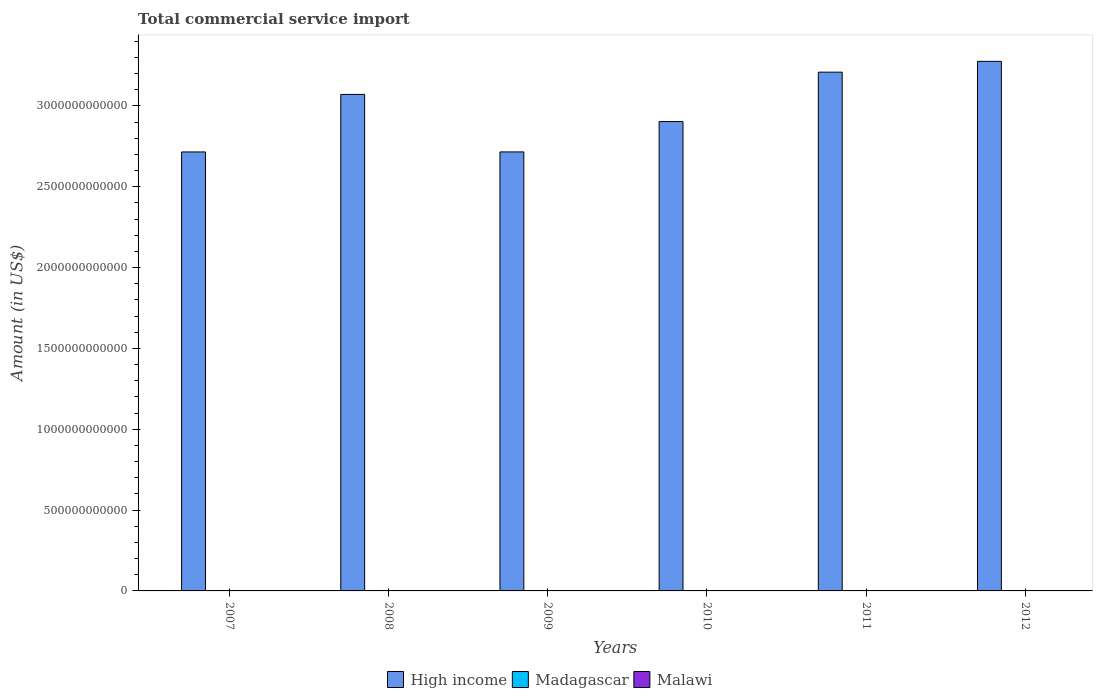How many different coloured bars are there?
Offer a terse response. 3. Are the number of bars on each tick of the X-axis equal?
Provide a succinct answer. Yes. What is the label of the 4th group of bars from the left?
Ensure brevity in your answer.  2010. What is the total commercial service import in Madagascar in 2010?
Give a very brief answer. 1.10e+09. Across all years, what is the maximum total commercial service import in High income?
Your answer should be very brief. 3.28e+12. Across all years, what is the minimum total commercial service import in Malawi?
Provide a succinct answer. 1.33e+08. In which year was the total commercial service import in High income maximum?
Keep it short and to the point. 2012. What is the total total commercial service import in High income in the graph?
Offer a very short reply. 1.79e+13. What is the difference between the total commercial service import in Madagascar in 2009 and that in 2012?
Provide a short and direct response. -4.01e+06. What is the difference between the total commercial service import in High income in 2008 and the total commercial service import in Madagascar in 2011?
Make the answer very short. 3.07e+12. What is the average total commercial service import in Madagascar per year?
Make the answer very short. 1.14e+09. In the year 2011, what is the difference between the total commercial service import in Madagascar and total commercial service import in Malawi?
Your answer should be very brief. 9.90e+08. What is the ratio of the total commercial service import in High income in 2008 to that in 2009?
Your answer should be very brief. 1.13. Is the difference between the total commercial service import in Madagascar in 2008 and 2009 greater than the difference between the total commercial service import in Malawi in 2008 and 2009?
Your answer should be compact. Yes. What is the difference between the highest and the second highest total commercial service import in Malawi?
Ensure brevity in your answer.  5.09e+07. What is the difference between the highest and the lowest total commercial service import in Malawi?
Give a very brief answer. 7.16e+07. Is the sum of the total commercial service import in Malawi in 2009 and 2010 greater than the maximum total commercial service import in Madagascar across all years?
Make the answer very short. No. What does the 3rd bar from the left in 2009 represents?
Offer a very short reply. Malawi. Is it the case that in every year, the sum of the total commercial service import in Madagascar and total commercial service import in High income is greater than the total commercial service import in Malawi?
Your answer should be compact. Yes. What is the difference between two consecutive major ticks on the Y-axis?
Give a very brief answer. 5.00e+11. Are the values on the major ticks of Y-axis written in scientific E-notation?
Offer a very short reply. No. Does the graph contain any zero values?
Provide a short and direct response. No. Does the graph contain grids?
Make the answer very short. No. Where does the legend appear in the graph?
Your response must be concise. Bottom center. How many legend labels are there?
Ensure brevity in your answer.  3. How are the legend labels stacked?
Provide a succinct answer. Horizontal. What is the title of the graph?
Offer a very short reply. Total commercial service import. Does "Azerbaijan" appear as one of the legend labels in the graph?
Offer a very short reply. No. What is the label or title of the X-axis?
Offer a terse response. Years. What is the label or title of the Y-axis?
Provide a succinct answer. Amount (in US$). What is the Amount (in US$) in High income in 2007?
Your response must be concise. 2.72e+12. What is the Amount (in US$) of Madagascar in 2007?
Give a very brief answer. 1.00e+09. What is the Amount (in US$) in Malawi in 2007?
Ensure brevity in your answer.  1.41e+08. What is the Amount (in US$) of High income in 2008?
Provide a succinct answer. 3.07e+12. What is the Amount (in US$) in Madagascar in 2008?
Your response must be concise. 1.35e+09. What is the Amount (in US$) in Malawi in 2008?
Make the answer very short. 1.33e+08. What is the Amount (in US$) in High income in 2009?
Your response must be concise. 2.72e+12. What is the Amount (in US$) of Madagascar in 2009?
Keep it short and to the point. 1.11e+09. What is the Amount (in US$) in Malawi in 2009?
Your answer should be compact. 1.36e+08. What is the Amount (in US$) of High income in 2010?
Offer a very short reply. 2.90e+12. What is the Amount (in US$) in Madagascar in 2010?
Provide a succinct answer. 1.10e+09. What is the Amount (in US$) in Malawi in 2010?
Ensure brevity in your answer.  1.35e+08. What is the Amount (in US$) in High income in 2011?
Give a very brief answer. 3.21e+12. What is the Amount (in US$) in Madagascar in 2011?
Your answer should be compact. 1.14e+09. What is the Amount (in US$) in Malawi in 2011?
Your answer should be compact. 1.54e+08. What is the Amount (in US$) in High income in 2012?
Your response must be concise. 3.28e+12. What is the Amount (in US$) of Madagascar in 2012?
Provide a short and direct response. 1.12e+09. What is the Amount (in US$) in Malawi in 2012?
Make the answer very short. 2.05e+08. Across all years, what is the maximum Amount (in US$) in High income?
Offer a very short reply. 3.28e+12. Across all years, what is the maximum Amount (in US$) of Madagascar?
Offer a very short reply. 1.35e+09. Across all years, what is the maximum Amount (in US$) in Malawi?
Provide a short and direct response. 2.05e+08. Across all years, what is the minimum Amount (in US$) in High income?
Make the answer very short. 2.72e+12. Across all years, what is the minimum Amount (in US$) of Madagascar?
Keep it short and to the point. 1.00e+09. Across all years, what is the minimum Amount (in US$) in Malawi?
Your response must be concise. 1.33e+08. What is the total Amount (in US$) of High income in the graph?
Make the answer very short. 1.79e+13. What is the total Amount (in US$) of Madagascar in the graph?
Provide a short and direct response. 6.83e+09. What is the total Amount (in US$) of Malawi in the graph?
Offer a very short reply. 9.04e+08. What is the difference between the Amount (in US$) in High income in 2007 and that in 2008?
Offer a terse response. -3.56e+11. What is the difference between the Amount (in US$) in Madagascar in 2007 and that in 2008?
Provide a short and direct response. -3.45e+08. What is the difference between the Amount (in US$) of Malawi in 2007 and that in 2008?
Offer a terse response. 7.50e+06. What is the difference between the Amount (in US$) of High income in 2007 and that in 2009?
Offer a very short reply. -1.42e+08. What is the difference between the Amount (in US$) of Madagascar in 2007 and that in 2009?
Offer a terse response. -1.09e+08. What is the difference between the Amount (in US$) of Malawi in 2007 and that in 2009?
Make the answer very short. 4.24e+06. What is the difference between the Amount (in US$) in High income in 2007 and that in 2010?
Your answer should be very brief. -1.88e+11. What is the difference between the Amount (in US$) in Madagascar in 2007 and that in 2010?
Ensure brevity in your answer.  -9.25e+07. What is the difference between the Amount (in US$) in Malawi in 2007 and that in 2010?
Your answer should be very brief. 5.56e+06. What is the difference between the Amount (in US$) of High income in 2007 and that in 2011?
Keep it short and to the point. -4.94e+11. What is the difference between the Amount (in US$) in Madagascar in 2007 and that in 2011?
Provide a short and direct response. -1.39e+08. What is the difference between the Amount (in US$) in Malawi in 2007 and that in 2011?
Your response must be concise. -1.32e+07. What is the difference between the Amount (in US$) in High income in 2007 and that in 2012?
Provide a short and direct response. -5.60e+11. What is the difference between the Amount (in US$) in Madagascar in 2007 and that in 2012?
Your answer should be compact. -1.13e+08. What is the difference between the Amount (in US$) in Malawi in 2007 and that in 2012?
Provide a succinct answer. -6.41e+07. What is the difference between the Amount (in US$) in High income in 2008 and that in 2009?
Keep it short and to the point. 3.56e+11. What is the difference between the Amount (in US$) in Madagascar in 2008 and that in 2009?
Your response must be concise. 2.36e+08. What is the difference between the Amount (in US$) of Malawi in 2008 and that in 2009?
Your response must be concise. -3.27e+06. What is the difference between the Amount (in US$) of High income in 2008 and that in 2010?
Provide a succinct answer. 1.68e+11. What is the difference between the Amount (in US$) in Madagascar in 2008 and that in 2010?
Give a very brief answer. 2.53e+08. What is the difference between the Amount (in US$) in Malawi in 2008 and that in 2010?
Your answer should be compact. -1.94e+06. What is the difference between the Amount (in US$) in High income in 2008 and that in 2011?
Your response must be concise. -1.38e+11. What is the difference between the Amount (in US$) in Madagascar in 2008 and that in 2011?
Keep it short and to the point. 2.07e+08. What is the difference between the Amount (in US$) of Malawi in 2008 and that in 2011?
Your answer should be compact. -2.07e+07. What is the difference between the Amount (in US$) in High income in 2008 and that in 2012?
Offer a terse response. -2.05e+11. What is the difference between the Amount (in US$) in Madagascar in 2008 and that in 2012?
Keep it short and to the point. 2.32e+08. What is the difference between the Amount (in US$) in Malawi in 2008 and that in 2012?
Keep it short and to the point. -7.16e+07. What is the difference between the Amount (in US$) in High income in 2009 and that in 2010?
Ensure brevity in your answer.  -1.88e+11. What is the difference between the Amount (in US$) of Madagascar in 2009 and that in 2010?
Offer a terse response. 1.64e+07. What is the difference between the Amount (in US$) of Malawi in 2009 and that in 2010?
Your response must be concise. 1.33e+06. What is the difference between the Amount (in US$) of High income in 2009 and that in 2011?
Give a very brief answer. -4.93e+11. What is the difference between the Amount (in US$) of Madagascar in 2009 and that in 2011?
Provide a succinct answer. -2.98e+07. What is the difference between the Amount (in US$) of Malawi in 2009 and that in 2011?
Provide a short and direct response. -1.74e+07. What is the difference between the Amount (in US$) in High income in 2009 and that in 2012?
Your answer should be very brief. -5.60e+11. What is the difference between the Amount (in US$) of Madagascar in 2009 and that in 2012?
Provide a succinct answer. -4.01e+06. What is the difference between the Amount (in US$) in Malawi in 2009 and that in 2012?
Give a very brief answer. -6.84e+07. What is the difference between the Amount (in US$) in High income in 2010 and that in 2011?
Your answer should be compact. -3.06e+11. What is the difference between the Amount (in US$) of Madagascar in 2010 and that in 2011?
Your answer should be very brief. -4.62e+07. What is the difference between the Amount (in US$) of Malawi in 2010 and that in 2011?
Your response must be concise. -1.87e+07. What is the difference between the Amount (in US$) of High income in 2010 and that in 2012?
Offer a very short reply. -3.72e+11. What is the difference between the Amount (in US$) of Madagascar in 2010 and that in 2012?
Ensure brevity in your answer.  -2.04e+07. What is the difference between the Amount (in US$) in Malawi in 2010 and that in 2012?
Ensure brevity in your answer.  -6.97e+07. What is the difference between the Amount (in US$) in High income in 2011 and that in 2012?
Provide a short and direct response. -6.69e+1. What is the difference between the Amount (in US$) of Madagascar in 2011 and that in 2012?
Your answer should be compact. 2.58e+07. What is the difference between the Amount (in US$) in Malawi in 2011 and that in 2012?
Provide a short and direct response. -5.09e+07. What is the difference between the Amount (in US$) of High income in 2007 and the Amount (in US$) of Madagascar in 2008?
Provide a succinct answer. 2.71e+12. What is the difference between the Amount (in US$) of High income in 2007 and the Amount (in US$) of Malawi in 2008?
Make the answer very short. 2.72e+12. What is the difference between the Amount (in US$) in Madagascar in 2007 and the Amount (in US$) in Malawi in 2008?
Keep it short and to the point. 8.72e+08. What is the difference between the Amount (in US$) in High income in 2007 and the Amount (in US$) in Madagascar in 2009?
Keep it short and to the point. 2.71e+12. What is the difference between the Amount (in US$) of High income in 2007 and the Amount (in US$) of Malawi in 2009?
Provide a succinct answer. 2.72e+12. What is the difference between the Amount (in US$) of Madagascar in 2007 and the Amount (in US$) of Malawi in 2009?
Offer a terse response. 8.69e+08. What is the difference between the Amount (in US$) in High income in 2007 and the Amount (in US$) in Madagascar in 2010?
Your answer should be very brief. 2.71e+12. What is the difference between the Amount (in US$) of High income in 2007 and the Amount (in US$) of Malawi in 2010?
Your answer should be compact. 2.72e+12. What is the difference between the Amount (in US$) of Madagascar in 2007 and the Amount (in US$) of Malawi in 2010?
Give a very brief answer. 8.70e+08. What is the difference between the Amount (in US$) of High income in 2007 and the Amount (in US$) of Madagascar in 2011?
Your answer should be compact. 2.71e+12. What is the difference between the Amount (in US$) in High income in 2007 and the Amount (in US$) in Malawi in 2011?
Your answer should be very brief. 2.72e+12. What is the difference between the Amount (in US$) in Madagascar in 2007 and the Amount (in US$) in Malawi in 2011?
Give a very brief answer. 8.51e+08. What is the difference between the Amount (in US$) in High income in 2007 and the Amount (in US$) in Madagascar in 2012?
Offer a terse response. 2.71e+12. What is the difference between the Amount (in US$) of High income in 2007 and the Amount (in US$) of Malawi in 2012?
Provide a succinct answer. 2.72e+12. What is the difference between the Amount (in US$) in Madagascar in 2007 and the Amount (in US$) in Malawi in 2012?
Keep it short and to the point. 8.00e+08. What is the difference between the Amount (in US$) of High income in 2008 and the Amount (in US$) of Madagascar in 2009?
Offer a very short reply. 3.07e+12. What is the difference between the Amount (in US$) in High income in 2008 and the Amount (in US$) in Malawi in 2009?
Give a very brief answer. 3.07e+12. What is the difference between the Amount (in US$) of Madagascar in 2008 and the Amount (in US$) of Malawi in 2009?
Offer a very short reply. 1.21e+09. What is the difference between the Amount (in US$) of High income in 2008 and the Amount (in US$) of Madagascar in 2010?
Offer a very short reply. 3.07e+12. What is the difference between the Amount (in US$) in High income in 2008 and the Amount (in US$) in Malawi in 2010?
Your response must be concise. 3.07e+12. What is the difference between the Amount (in US$) of Madagascar in 2008 and the Amount (in US$) of Malawi in 2010?
Your response must be concise. 1.22e+09. What is the difference between the Amount (in US$) of High income in 2008 and the Amount (in US$) of Madagascar in 2011?
Provide a succinct answer. 3.07e+12. What is the difference between the Amount (in US$) of High income in 2008 and the Amount (in US$) of Malawi in 2011?
Your answer should be very brief. 3.07e+12. What is the difference between the Amount (in US$) in Madagascar in 2008 and the Amount (in US$) in Malawi in 2011?
Provide a short and direct response. 1.20e+09. What is the difference between the Amount (in US$) in High income in 2008 and the Amount (in US$) in Madagascar in 2012?
Your response must be concise. 3.07e+12. What is the difference between the Amount (in US$) of High income in 2008 and the Amount (in US$) of Malawi in 2012?
Keep it short and to the point. 3.07e+12. What is the difference between the Amount (in US$) of Madagascar in 2008 and the Amount (in US$) of Malawi in 2012?
Give a very brief answer. 1.15e+09. What is the difference between the Amount (in US$) of High income in 2009 and the Amount (in US$) of Madagascar in 2010?
Offer a terse response. 2.71e+12. What is the difference between the Amount (in US$) in High income in 2009 and the Amount (in US$) in Malawi in 2010?
Your answer should be very brief. 2.72e+12. What is the difference between the Amount (in US$) in Madagascar in 2009 and the Amount (in US$) in Malawi in 2010?
Your response must be concise. 9.79e+08. What is the difference between the Amount (in US$) in High income in 2009 and the Amount (in US$) in Madagascar in 2011?
Your answer should be compact. 2.71e+12. What is the difference between the Amount (in US$) in High income in 2009 and the Amount (in US$) in Malawi in 2011?
Provide a short and direct response. 2.72e+12. What is the difference between the Amount (in US$) of Madagascar in 2009 and the Amount (in US$) of Malawi in 2011?
Offer a very short reply. 9.60e+08. What is the difference between the Amount (in US$) in High income in 2009 and the Amount (in US$) in Madagascar in 2012?
Your response must be concise. 2.71e+12. What is the difference between the Amount (in US$) of High income in 2009 and the Amount (in US$) of Malawi in 2012?
Your answer should be very brief. 2.72e+12. What is the difference between the Amount (in US$) of Madagascar in 2009 and the Amount (in US$) of Malawi in 2012?
Offer a terse response. 9.09e+08. What is the difference between the Amount (in US$) in High income in 2010 and the Amount (in US$) in Madagascar in 2011?
Give a very brief answer. 2.90e+12. What is the difference between the Amount (in US$) of High income in 2010 and the Amount (in US$) of Malawi in 2011?
Ensure brevity in your answer.  2.90e+12. What is the difference between the Amount (in US$) in Madagascar in 2010 and the Amount (in US$) in Malawi in 2011?
Provide a short and direct response. 9.44e+08. What is the difference between the Amount (in US$) in High income in 2010 and the Amount (in US$) in Madagascar in 2012?
Provide a short and direct response. 2.90e+12. What is the difference between the Amount (in US$) in High income in 2010 and the Amount (in US$) in Malawi in 2012?
Offer a very short reply. 2.90e+12. What is the difference between the Amount (in US$) in Madagascar in 2010 and the Amount (in US$) in Malawi in 2012?
Your answer should be very brief. 8.93e+08. What is the difference between the Amount (in US$) in High income in 2011 and the Amount (in US$) in Madagascar in 2012?
Ensure brevity in your answer.  3.21e+12. What is the difference between the Amount (in US$) in High income in 2011 and the Amount (in US$) in Malawi in 2012?
Keep it short and to the point. 3.21e+12. What is the difference between the Amount (in US$) of Madagascar in 2011 and the Amount (in US$) of Malawi in 2012?
Your response must be concise. 9.39e+08. What is the average Amount (in US$) of High income per year?
Make the answer very short. 2.98e+12. What is the average Amount (in US$) in Madagascar per year?
Offer a very short reply. 1.14e+09. What is the average Amount (in US$) in Malawi per year?
Your answer should be very brief. 1.51e+08. In the year 2007, what is the difference between the Amount (in US$) of High income and Amount (in US$) of Madagascar?
Your answer should be compact. 2.71e+12. In the year 2007, what is the difference between the Amount (in US$) in High income and Amount (in US$) in Malawi?
Your answer should be very brief. 2.72e+12. In the year 2007, what is the difference between the Amount (in US$) in Madagascar and Amount (in US$) in Malawi?
Ensure brevity in your answer.  8.64e+08. In the year 2008, what is the difference between the Amount (in US$) in High income and Amount (in US$) in Madagascar?
Offer a terse response. 3.07e+12. In the year 2008, what is the difference between the Amount (in US$) of High income and Amount (in US$) of Malawi?
Your answer should be compact. 3.07e+12. In the year 2008, what is the difference between the Amount (in US$) of Madagascar and Amount (in US$) of Malawi?
Your answer should be compact. 1.22e+09. In the year 2009, what is the difference between the Amount (in US$) of High income and Amount (in US$) of Madagascar?
Offer a terse response. 2.71e+12. In the year 2009, what is the difference between the Amount (in US$) in High income and Amount (in US$) in Malawi?
Offer a terse response. 2.72e+12. In the year 2009, what is the difference between the Amount (in US$) in Madagascar and Amount (in US$) in Malawi?
Your answer should be compact. 9.77e+08. In the year 2010, what is the difference between the Amount (in US$) in High income and Amount (in US$) in Madagascar?
Your answer should be very brief. 2.90e+12. In the year 2010, what is the difference between the Amount (in US$) of High income and Amount (in US$) of Malawi?
Give a very brief answer. 2.90e+12. In the year 2010, what is the difference between the Amount (in US$) in Madagascar and Amount (in US$) in Malawi?
Provide a succinct answer. 9.62e+08. In the year 2011, what is the difference between the Amount (in US$) of High income and Amount (in US$) of Madagascar?
Make the answer very short. 3.21e+12. In the year 2011, what is the difference between the Amount (in US$) in High income and Amount (in US$) in Malawi?
Offer a terse response. 3.21e+12. In the year 2011, what is the difference between the Amount (in US$) of Madagascar and Amount (in US$) of Malawi?
Your response must be concise. 9.90e+08. In the year 2012, what is the difference between the Amount (in US$) of High income and Amount (in US$) of Madagascar?
Offer a very short reply. 3.27e+12. In the year 2012, what is the difference between the Amount (in US$) of High income and Amount (in US$) of Malawi?
Provide a short and direct response. 3.28e+12. In the year 2012, what is the difference between the Amount (in US$) of Madagascar and Amount (in US$) of Malawi?
Give a very brief answer. 9.13e+08. What is the ratio of the Amount (in US$) of High income in 2007 to that in 2008?
Your response must be concise. 0.88. What is the ratio of the Amount (in US$) in Madagascar in 2007 to that in 2008?
Offer a terse response. 0.74. What is the ratio of the Amount (in US$) in Malawi in 2007 to that in 2008?
Make the answer very short. 1.06. What is the ratio of the Amount (in US$) in Madagascar in 2007 to that in 2009?
Provide a succinct answer. 0.9. What is the ratio of the Amount (in US$) in Malawi in 2007 to that in 2009?
Make the answer very short. 1.03. What is the ratio of the Amount (in US$) of High income in 2007 to that in 2010?
Your response must be concise. 0.94. What is the ratio of the Amount (in US$) in Madagascar in 2007 to that in 2010?
Your answer should be compact. 0.92. What is the ratio of the Amount (in US$) of Malawi in 2007 to that in 2010?
Ensure brevity in your answer.  1.04. What is the ratio of the Amount (in US$) of High income in 2007 to that in 2011?
Offer a very short reply. 0.85. What is the ratio of the Amount (in US$) of Madagascar in 2007 to that in 2011?
Offer a terse response. 0.88. What is the ratio of the Amount (in US$) of Malawi in 2007 to that in 2011?
Provide a short and direct response. 0.91. What is the ratio of the Amount (in US$) of High income in 2007 to that in 2012?
Provide a succinct answer. 0.83. What is the ratio of the Amount (in US$) in Madagascar in 2007 to that in 2012?
Provide a short and direct response. 0.9. What is the ratio of the Amount (in US$) in Malawi in 2007 to that in 2012?
Provide a succinct answer. 0.69. What is the ratio of the Amount (in US$) of High income in 2008 to that in 2009?
Offer a terse response. 1.13. What is the ratio of the Amount (in US$) in Madagascar in 2008 to that in 2009?
Your response must be concise. 1.21. What is the ratio of the Amount (in US$) in Malawi in 2008 to that in 2009?
Your answer should be very brief. 0.98. What is the ratio of the Amount (in US$) of High income in 2008 to that in 2010?
Offer a terse response. 1.06. What is the ratio of the Amount (in US$) of Madagascar in 2008 to that in 2010?
Offer a very short reply. 1.23. What is the ratio of the Amount (in US$) in Malawi in 2008 to that in 2010?
Keep it short and to the point. 0.99. What is the ratio of the Amount (in US$) of High income in 2008 to that in 2011?
Your answer should be very brief. 0.96. What is the ratio of the Amount (in US$) in Madagascar in 2008 to that in 2011?
Provide a short and direct response. 1.18. What is the ratio of the Amount (in US$) of Malawi in 2008 to that in 2011?
Provide a short and direct response. 0.87. What is the ratio of the Amount (in US$) of High income in 2008 to that in 2012?
Ensure brevity in your answer.  0.94. What is the ratio of the Amount (in US$) in Madagascar in 2008 to that in 2012?
Your answer should be very brief. 1.21. What is the ratio of the Amount (in US$) in Malawi in 2008 to that in 2012?
Your answer should be very brief. 0.65. What is the ratio of the Amount (in US$) of High income in 2009 to that in 2010?
Your answer should be very brief. 0.94. What is the ratio of the Amount (in US$) in Madagascar in 2009 to that in 2010?
Your answer should be very brief. 1.01. What is the ratio of the Amount (in US$) in Malawi in 2009 to that in 2010?
Give a very brief answer. 1.01. What is the ratio of the Amount (in US$) of High income in 2009 to that in 2011?
Your response must be concise. 0.85. What is the ratio of the Amount (in US$) in Madagascar in 2009 to that in 2011?
Your response must be concise. 0.97. What is the ratio of the Amount (in US$) of Malawi in 2009 to that in 2011?
Ensure brevity in your answer.  0.89. What is the ratio of the Amount (in US$) of High income in 2009 to that in 2012?
Your answer should be compact. 0.83. What is the ratio of the Amount (in US$) of Malawi in 2009 to that in 2012?
Make the answer very short. 0.67. What is the ratio of the Amount (in US$) in High income in 2010 to that in 2011?
Offer a very short reply. 0.9. What is the ratio of the Amount (in US$) in Madagascar in 2010 to that in 2011?
Provide a short and direct response. 0.96. What is the ratio of the Amount (in US$) of Malawi in 2010 to that in 2011?
Provide a succinct answer. 0.88. What is the ratio of the Amount (in US$) in High income in 2010 to that in 2012?
Offer a very short reply. 0.89. What is the ratio of the Amount (in US$) of Madagascar in 2010 to that in 2012?
Your answer should be very brief. 0.98. What is the ratio of the Amount (in US$) in Malawi in 2010 to that in 2012?
Keep it short and to the point. 0.66. What is the ratio of the Amount (in US$) of High income in 2011 to that in 2012?
Your answer should be compact. 0.98. What is the ratio of the Amount (in US$) of Madagascar in 2011 to that in 2012?
Provide a succinct answer. 1.02. What is the ratio of the Amount (in US$) of Malawi in 2011 to that in 2012?
Provide a short and direct response. 0.75. What is the difference between the highest and the second highest Amount (in US$) in High income?
Ensure brevity in your answer.  6.69e+1. What is the difference between the highest and the second highest Amount (in US$) in Madagascar?
Offer a terse response. 2.07e+08. What is the difference between the highest and the second highest Amount (in US$) in Malawi?
Your response must be concise. 5.09e+07. What is the difference between the highest and the lowest Amount (in US$) of High income?
Keep it short and to the point. 5.60e+11. What is the difference between the highest and the lowest Amount (in US$) in Madagascar?
Offer a terse response. 3.45e+08. What is the difference between the highest and the lowest Amount (in US$) in Malawi?
Give a very brief answer. 7.16e+07. 